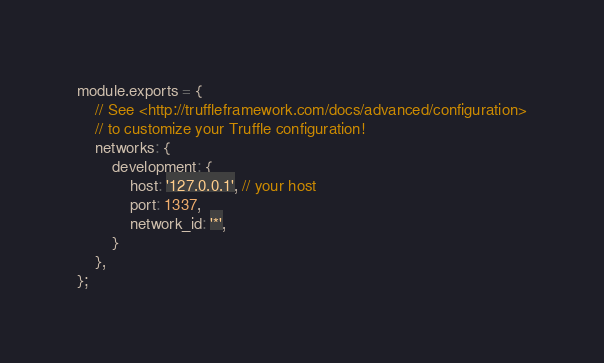<code> <loc_0><loc_0><loc_500><loc_500><_JavaScript_>module.exports = {
    // See <http://truffleframework.com/docs/advanced/configuration>
    // to customize your Truffle configuration!
    networks: {
        development: {
            host: '127.0.0.1', // your host
            port: 1337,
            network_id: '*',
        }
    },
};</code> 